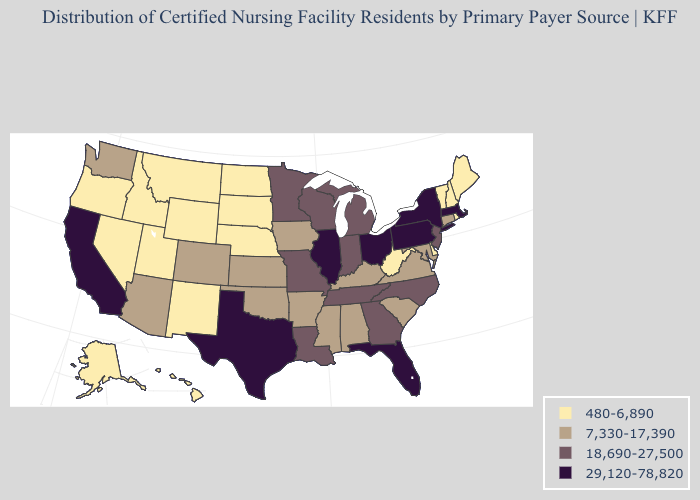Among the states that border Tennessee , does Georgia have the highest value?
Be succinct. Yes. Name the states that have a value in the range 18,690-27,500?
Be succinct. Georgia, Indiana, Louisiana, Michigan, Minnesota, Missouri, New Jersey, North Carolina, Tennessee, Wisconsin. Does the first symbol in the legend represent the smallest category?
Answer briefly. Yes. Which states have the highest value in the USA?
Quick response, please. California, Florida, Illinois, Massachusetts, New York, Ohio, Pennsylvania, Texas. Which states have the lowest value in the South?
Answer briefly. Delaware, West Virginia. What is the value of Tennessee?
Be succinct. 18,690-27,500. Name the states that have a value in the range 29,120-78,820?
Answer briefly. California, Florida, Illinois, Massachusetts, New York, Ohio, Pennsylvania, Texas. Among the states that border Pennsylvania , does Ohio have the highest value?
Write a very short answer. Yes. Does Kansas have a lower value than Nebraska?
Short answer required. No. What is the lowest value in states that border North Dakota?
Keep it brief. 480-6,890. Which states have the lowest value in the USA?
Concise answer only. Alaska, Delaware, Hawaii, Idaho, Maine, Montana, Nebraska, Nevada, New Hampshire, New Mexico, North Dakota, Oregon, Rhode Island, South Dakota, Utah, Vermont, West Virginia, Wyoming. Name the states that have a value in the range 480-6,890?
Quick response, please. Alaska, Delaware, Hawaii, Idaho, Maine, Montana, Nebraska, Nevada, New Hampshire, New Mexico, North Dakota, Oregon, Rhode Island, South Dakota, Utah, Vermont, West Virginia, Wyoming. Name the states that have a value in the range 480-6,890?
Keep it brief. Alaska, Delaware, Hawaii, Idaho, Maine, Montana, Nebraska, Nevada, New Hampshire, New Mexico, North Dakota, Oregon, Rhode Island, South Dakota, Utah, Vermont, West Virginia, Wyoming. What is the value of Maine?
Give a very brief answer. 480-6,890. What is the value of South Carolina?
Give a very brief answer. 7,330-17,390. 